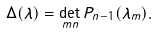<formula> <loc_0><loc_0><loc_500><loc_500>\Delta ( \lambda ) = \det _ { m n } P _ { n - 1 } ( \lambda _ { m } ) .</formula> 